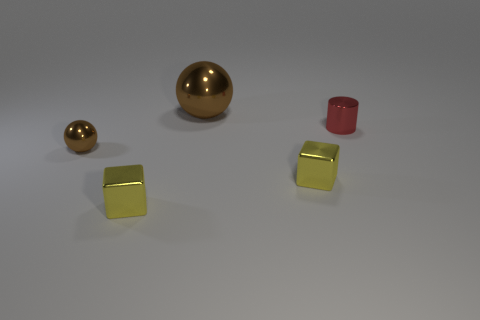Compare the textures between the cylinder and the spheres. Both the cylinder and the spheres showcase a smooth texture, but the cylinder has a matte finish that contrasts with the glossy, polished look of the spheres. Does the lighting affect the perception of the objects' colors? Yes, the overhead lighting enhances the luster of the metallic spheres and highlights the rich red of the cylinder, making the colors more vivid and appealing in the image. 